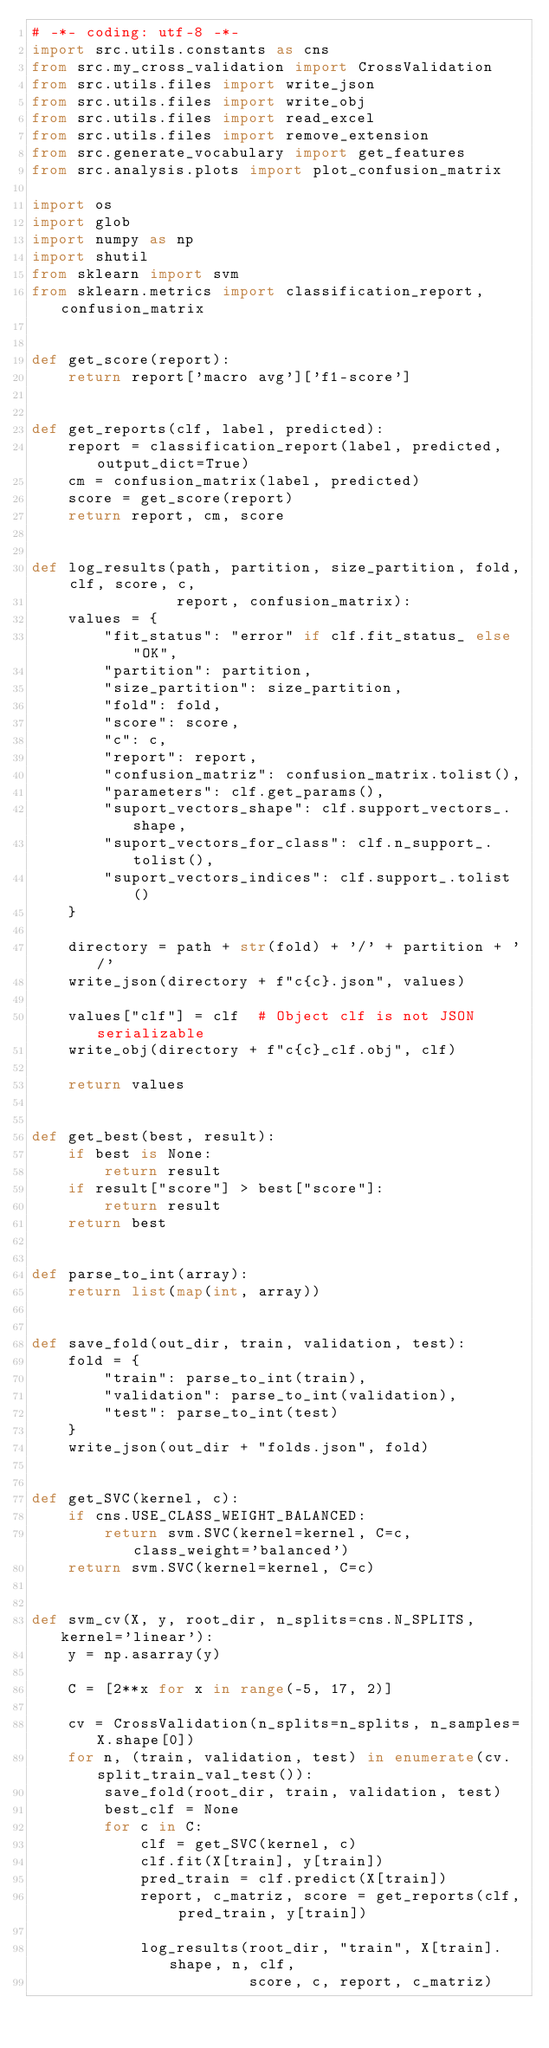Convert code to text. <code><loc_0><loc_0><loc_500><loc_500><_Python_># -*- coding: utf-8 -*-
import src.utils.constants as cns
from src.my_cross_validation import CrossValidation
from src.utils.files import write_json
from src.utils.files import write_obj
from src.utils.files import read_excel
from src.utils.files import remove_extension
from src.generate_vocabulary import get_features
from src.analysis.plots import plot_confusion_matrix

import os
import glob
import numpy as np
import shutil
from sklearn import svm
from sklearn.metrics import classification_report, confusion_matrix


def get_score(report):
    return report['macro avg']['f1-score']


def get_reports(clf, label, predicted):
    report = classification_report(label, predicted, output_dict=True)
    cm = confusion_matrix(label, predicted)
    score = get_score(report)
    return report, cm, score


def log_results(path, partition, size_partition, fold, clf, score, c,
                report, confusion_matrix):
    values = {
        "fit_status": "error" if clf.fit_status_ else "OK",
        "partition": partition,
        "size_partition": size_partition,
        "fold": fold,
        "score": score,
        "c": c,
        "report": report,
        "confusion_matriz": confusion_matrix.tolist(),
        "parameters": clf.get_params(),
        "suport_vectors_shape": clf.support_vectors_.shape,
        "suport_vectors_for_class": clf.n_support_.tolist(),
        "suport_vectors_indices": clf.support_.tolist()
    }

    directory = path + str(fold) + '/' + partition + '/'
    write_json(directory + f"c{c}.json", values)

    values["clf"] = clf  # Object clf is not JSON serializable
    write_obj(directory + f"c{c}_clf.obj", clf)

    return values


def get_best(best, result):
    if best is None:
        return result
    if result["score"] > best["score"]:
        return result
    return best


def parse_to_int(array):
    return list(map(int, array))


def save_fold(out_dir, train, validation, test):
    fold = {
        "train": parse_to_int(train),
        "validation": parse_to_int(validation),
        "test": parse_to_int(test)
    }
    write_json(out_dir + "folds.json", fold)


def get_SVC(kernel, c):
    if cns.USE_CLASS_WEIGHT_BALANCED:
        return svm.SVC(kernel=kernel, C=c, class_weight='balanced')
    return svm.SVC(kernel=kernel, C=c)


def svm_cv(X, y, root_dir, n_splits=cns.N_SPLITS, kernel='linear'):
    y = np.asarray(y)

    C = [2**x for x in range(-5, 17, 2)]

    cv = CrossValidation(n_splits=n_splits, n_samples=X.shape[0])
    for n, (train, validation, test) in enumerate(cv.split_train_val_test()):
        save_fold(root_dir, train, validation, test)
        best_clf = None
        for c in C:
            clf = get_SVC(kernel, c)
            clf.fit(X[train], y[train])
            pred_train = clf.predict(X[train])
            report, c_matriz, score = get_reports(clf, pred_train, y[train])

            log_results(root_dir, "train", X[train].shape, n, clf,
                        score, c, report, c_matriz)
</code> 